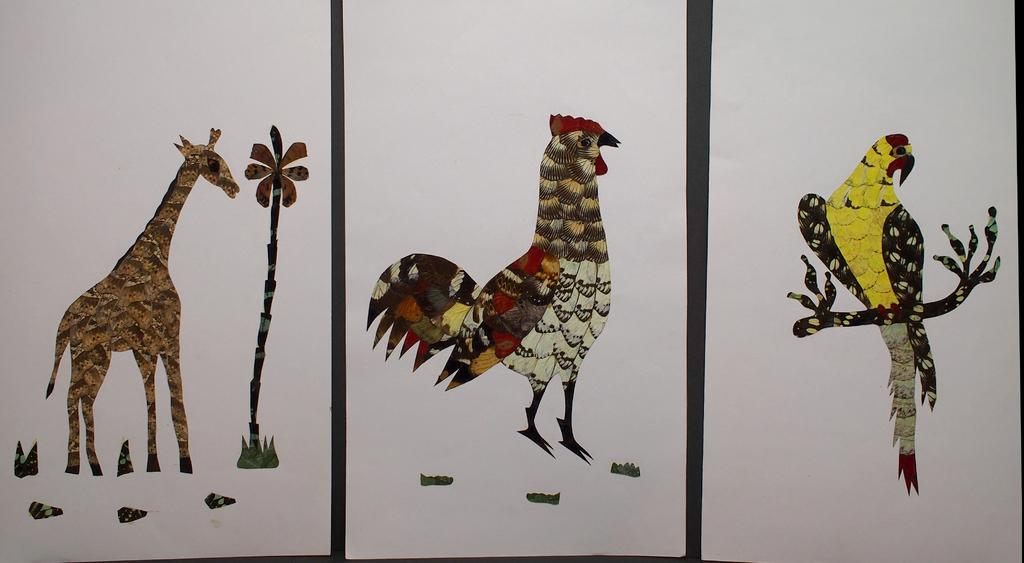What type of animal is in the image? There is a giraffe in the image. What else can be seen in the image besides the giraffe? There is a tree, a hen, a bird on a branch, and some objects in the image. Can you describe the bird in the image? The bird is on a branch in the image. What is visible in the background of the image? There is a wall visible in the background of the image. What type of jeans is the monkey wearing in the image? There is no monkey present in the image, and therefore no one is wearing jeans. Who is the manager of the giraffe in the image? The image does not depict a situation where a giraffe would have a manager, so this question cannot be answered. 